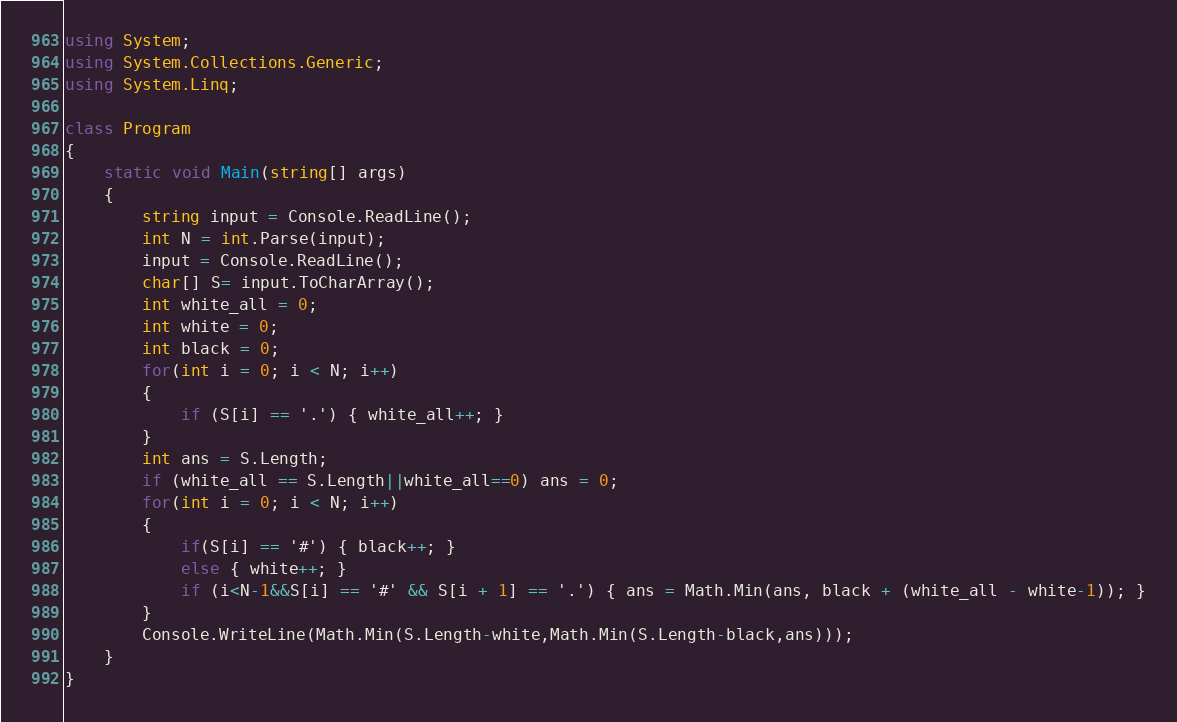<code> <loc_0><loc_0><loc_500><loc_500><_C#_>using System;
using System.Collections.Generic;
using System.Linq;

class Program
{
    static void Main(string[] args)
    {
        string input = Console.ReadLine();
        int N = int.Parse(input);
        input = Console.ReadLine();
        char[] S= input.ToCharArray();
        int white_all = 0;
        int white = 0;
        int black = 0;
        for(int i = 0; i < N; i++)
        {
            if (S[i] == '.') { white_all++; }
        }
        int ans = S.Length;
        if (white_all == S.Length||white_all==0) ans = 0;
        for(int i = 0; i < N; i++)
        {
            if(S[i] == '#') { black++; }
            else { white++; }
            if (i<N-1&&S[i] == '#' && S[i + 1] == '.') { ans = Math.Min(ans, black + (white_all - white-1)); }
        }
        Console.WriteLine(Math.Min(S.Length-white,Math.Min(S.Length-black,ans)));
    }
}</code> 